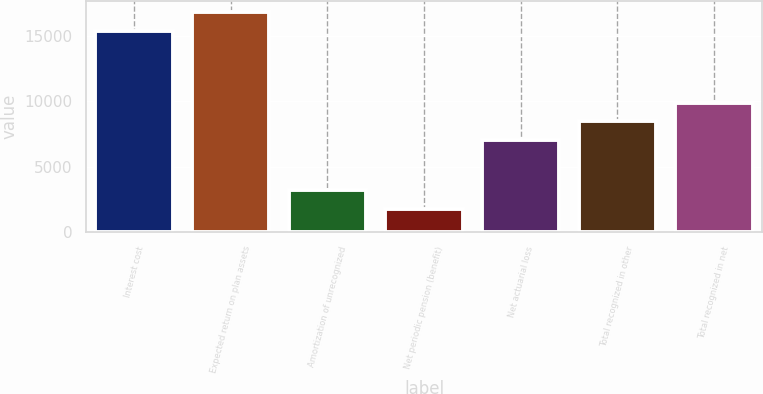Convert chart. <chart><loc_0><loc_0><loc_500><loc_500><bar_chart><fcel>Interest cost<fcel>Expected return on plan assets<fcel>Amortization of unrecognized<fcel>Net periodic pension (benefit)<fcel>Net actuarial loss<fcel>Total recognized in other<fcel>Total recognized in net<nl><fcel>15414<fcel>16846.1<fcel>3206.1<fcel>1774<fcel>7047<fcel>8479.1<fcel>9911.2<nl></chart> 